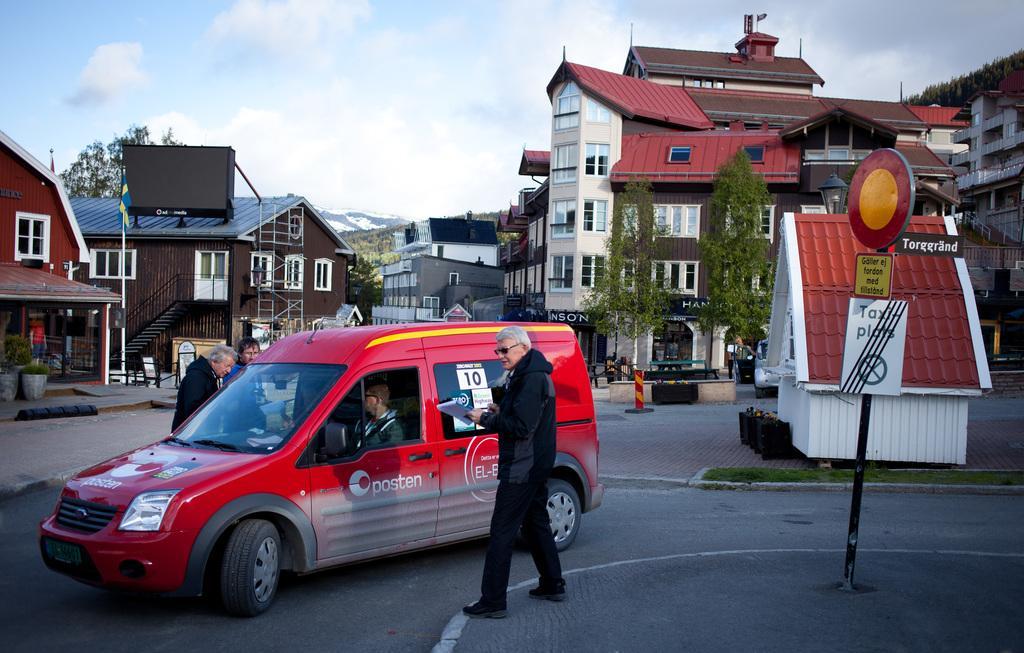Can you describe this image briefly? In this picture we can see a few people on the path. We can see vehicles, some text and a few things on the boards. There are plants, flower pots, buildings and some objects visible on the path. We can see other objects and the clouds in the sky. 